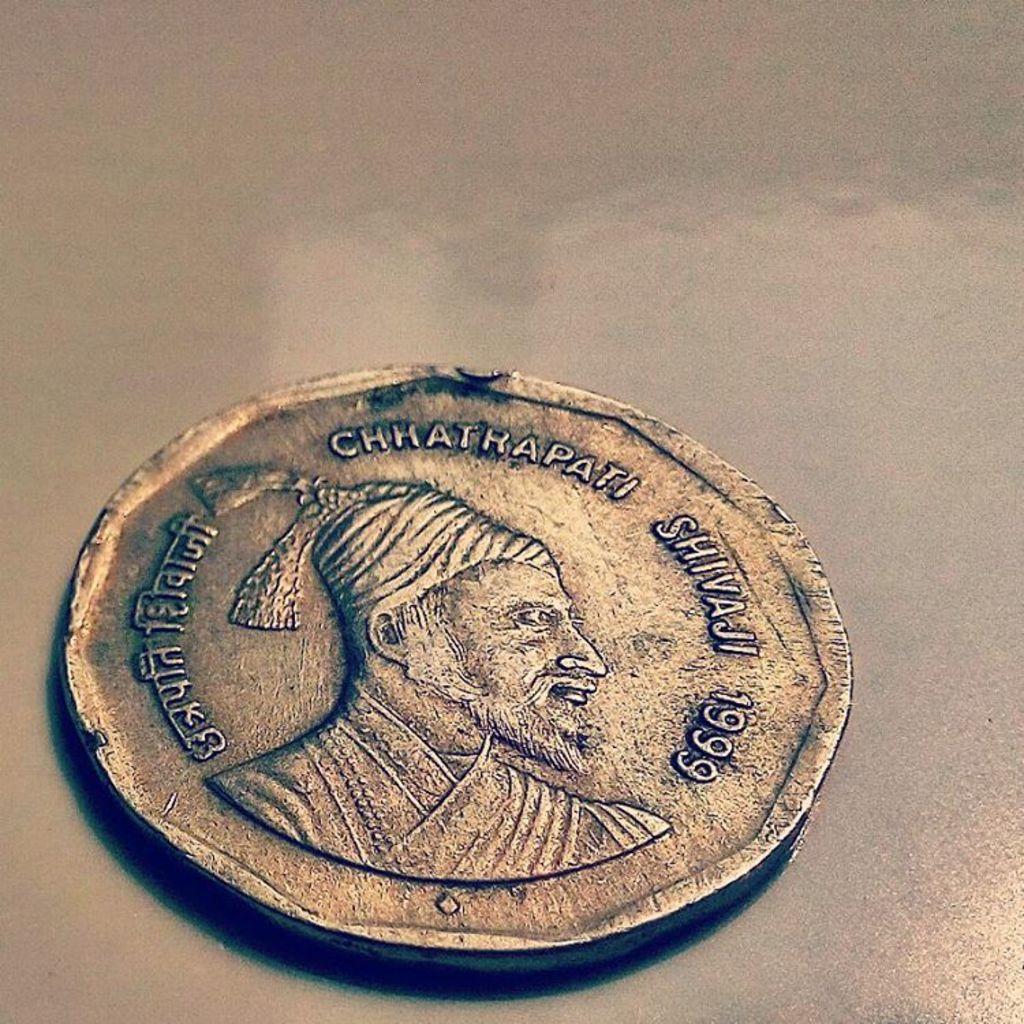What year is the coin from?
Your answer should be compact. 1999. What is the word shown before the year?
Offer a very short reply. Shivaji. 